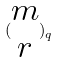<formula> <loc_0><loc_0><loc_500><loc_500>( \begin{matrix} m \\ r \end{matrix} ) _ { q }</formula> 